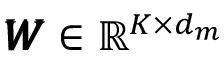Convert formula to latex. <formula><loc_0><loc_0><loc_500><loc_500>\pm b { W } \in \mathbb { R } ^ { K \times d _ { m } }</formula> 